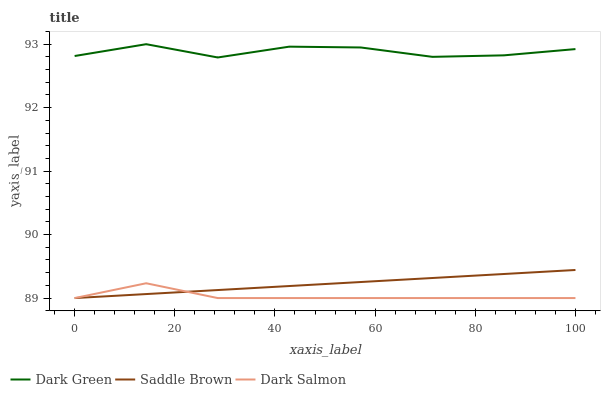Does Dark Salmon have the minimum area under the curve?
Answer yes or no. Yes. Does Saddle Brown have the minimum area under the curve?
Answer yes or no. No. Does Saddle Brown have the maximum area under the curve?
Answer yes or no. No. Is Dark Green the smoothest?
Answer yes or no. No. Is Saddle Brown the roughest?
Answer yes or no. No. Does Dark Green have the lowest value?
Answer yes or no. No. Does Saddle Brown have the highest value?
Answer yes or no. No. Is Saddle Brown less than Dark Green?
Answer yes or no. Yes. Is Dark Green greater than Dark Salmon?
Answer yes or no. Yes. Does Saddle Brown intersect Dark Green?
Answer yes or no. No. 